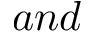<formula> <loc_0><loc_0><loc_500><loc_500>a n d</formula> 